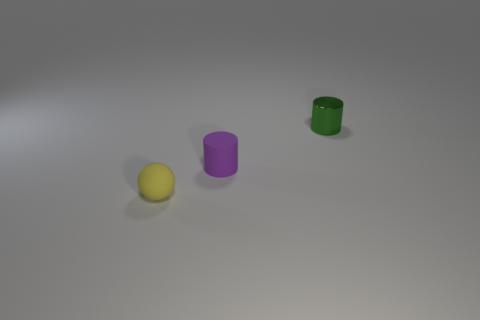Add 3 small yellow matte spheres. How many objects exist? 6 Subtract all cylinders. How many objects are left? 1 Subtract 0 brown balls. How many objects are left? 3 Subtract all green shiny blocks. Subtract all tiny green shiny objects. How many objects are left? 2 Add 3 purple rubber objects. How many purple rubber objects are left? 4 Add 3 small balls. How many small balls exist? 4 